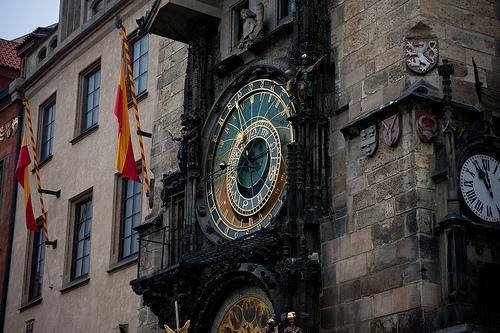State the color of the flags and where they are attached. The flags are yellow, red, and orange and are attached to the wall. What time does the white clock with black numbers show? The white clock with black numbers shows 11:55. What is the color of the sky in the image? The sky is blue and clear. Mention a unique feature of the building's windows. Rows of windows can be seen on the side of the building. What type of wall is the building made of? The wall is made of bricks and stones. Identify the color of the clock with the metallic frame. The clock with the metallic frame is green. What is the condition of the windows in the image? The windows are closed and clear. What do the elevated poles have on them? The elevated poles have yellow and red flags. Describe the position of the ring on the large rimmed circle. The ring is off-center on the large rimmed circle. Describe the appearance of the lion depicted in the image. The lion is stylized with spread claws, and it is located on a wall. 